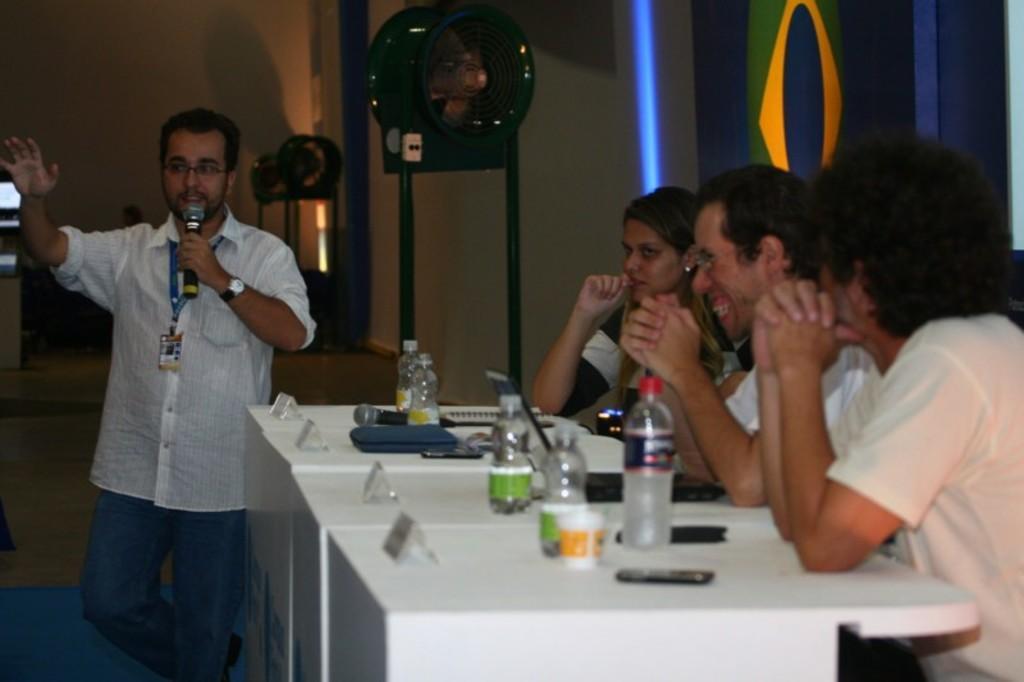Describe this image in one or two sentences. In this image there are few tables having bottles, mobile, cup and few objects on it. Left side a person is standing. He is holding a mike. He is wearing spectacles. Right side few persons are sitting behind the table. There are few lights attached to the stand which are on the floor. Background there is a wall. 